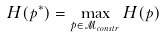<formula> <loc_0><loc_0><loc_500><loc_500>H ( p ^ { * } ) = \max _ { p \in \mathcal { M } _ { c o n s t r } } H ( p )</formula> 